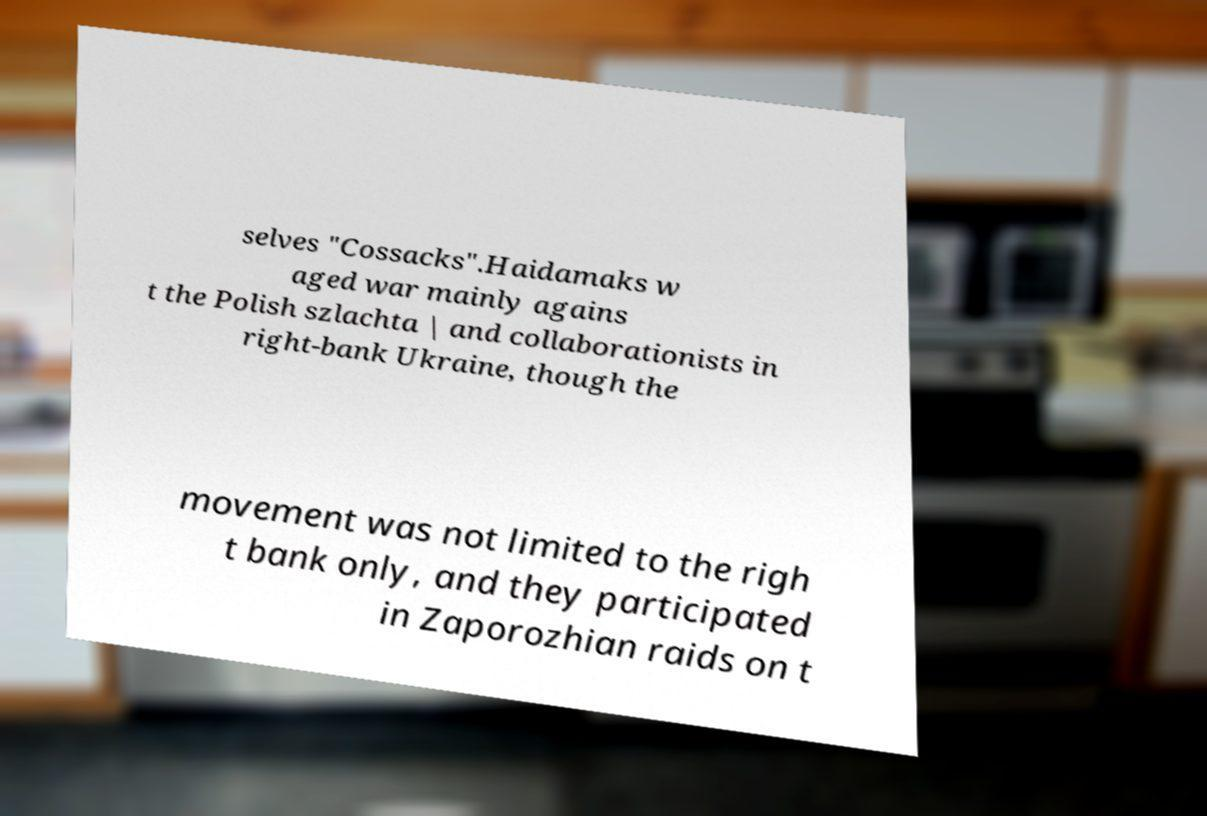Please read and relay the text visible in this image. What does it say? selves "Cossacks".Haidamaks w aged war mainly agains t the Polish szlachta | and collaborationists in right-bank Ukraine, though the movement was not limited to the righ t bank only, and they participated in Zaporozhian raids on t 